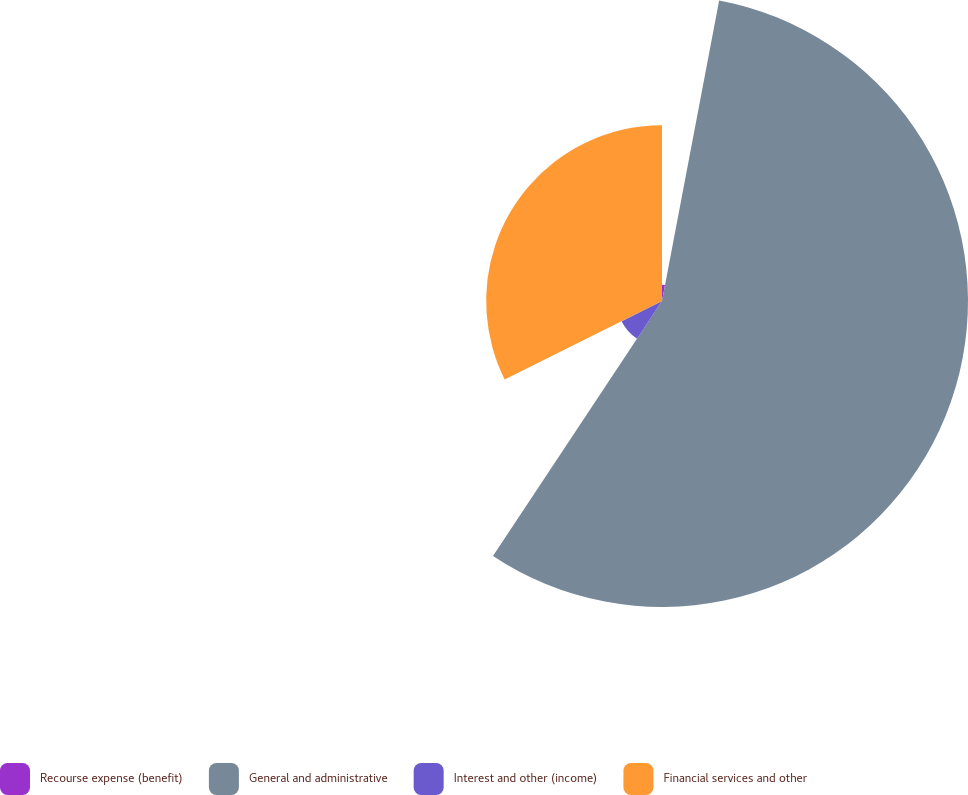Convert chart. <chart><loc_0><loc_0><loc_500><loc_500><pie_chart><fcel>Recourse expense (benefit)<fcel>General and administrative<fcel>Interest and other (income)<fcel>Financial services and other<nl><fcel>2.99%<fcel>56.33%<fcel>8.32%<fcel>32.37%<nl></chart> 